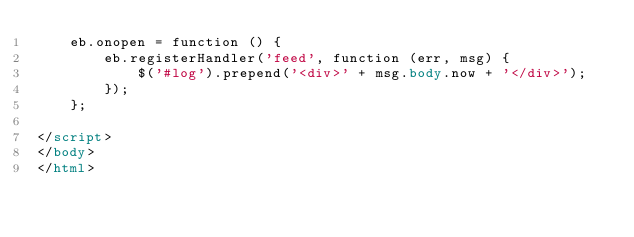Convert code to text. <code><loc_0><loc_0><loc_500><loc_500><_HTML_>    eb.onopen = function () {
        eb.registerHandler('feed', function (err, msg) {
            $('#log').prepend('<div>' + msg.body.now + '</div>');
        });
    };

</script>
</body>
</html>
</code> 